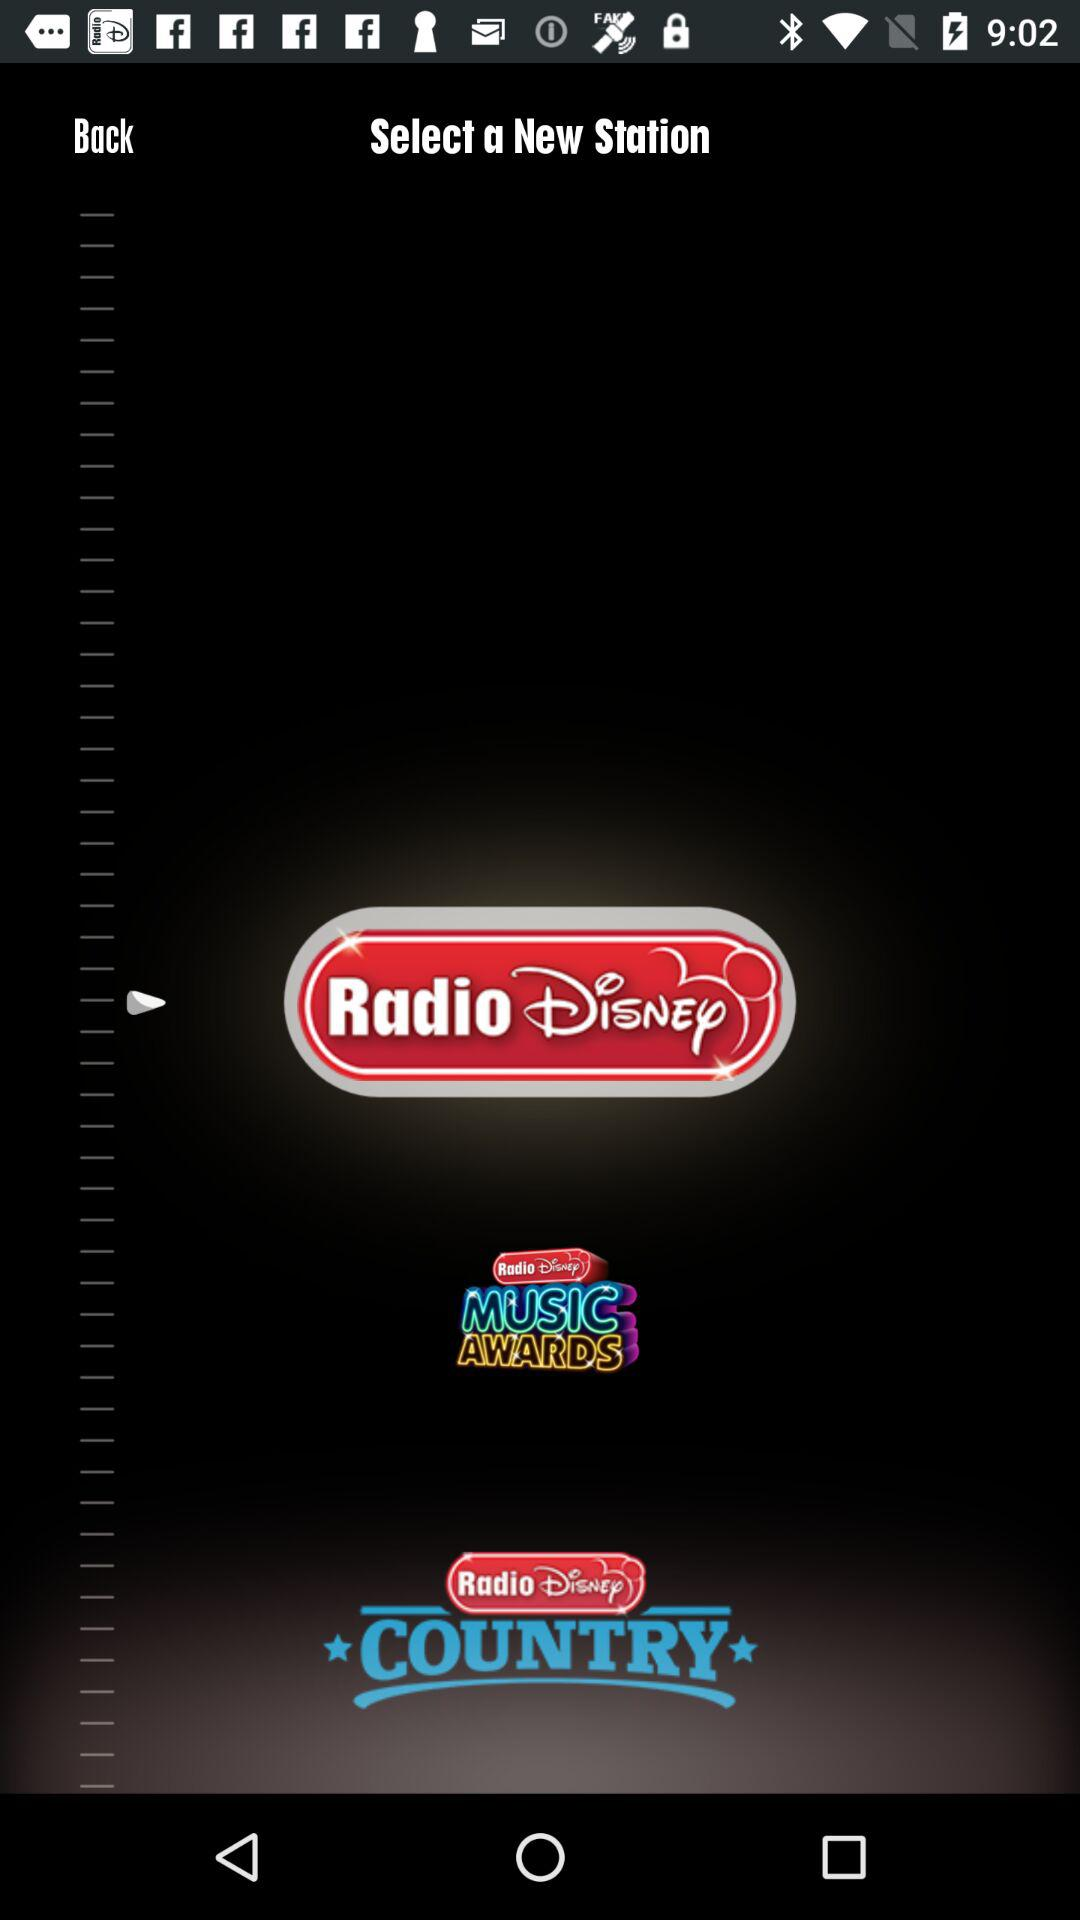What are the new radio stations? The new radio stations are "Radio Disney" and "Radio Disney COUNTRY". 